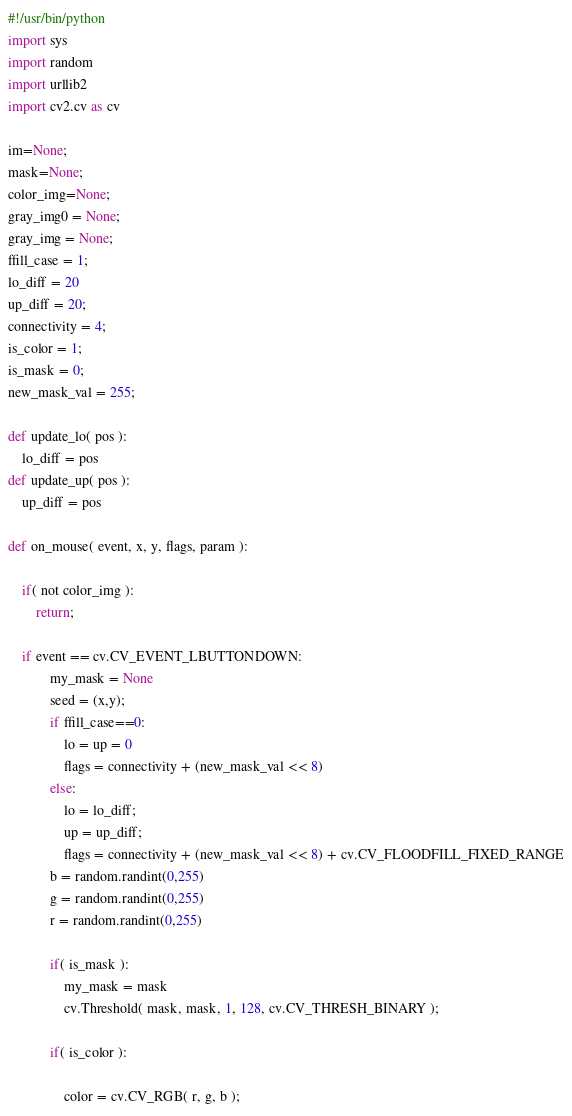Convert code to text. <code><loc_0><loc_0><loc_500><loc_500><_Python_>#!/usr/bin/python
import sys
import random
import urllib2
import cv2.cv as cv

im=None;
mask=None;
color_img=None;
gray_img0 = None;
gray_img = None;
ffill_case = 1;
lo_diff = 20
up_diff = 20;
connectivity = 4;
is_color = 1;
is_mask = 0;
new_mask_val = 255;

def update_lo( pos ):
    lo_diff = pos
def update_up( pos ):
    up_diff = pos

def on_mouse( event, x, y, flags, param ):

    if( not color_img ):
        return;

    if event == cv.CV_EVENT_LBUTTONDOWN:
            my_mask = None
            seed = (x,y);
            if ffill_case==0:
                lo = up = 0
                flags = connectivity + (new_mask_val << 8)
            else:
                lo = lo_diff;
                up = up_diff;
                flags = connectivity + (new_mask_val << 8) + cv.CV_FLOODFILL_FIXED_RANGE
            b = random.randint(0,255)
            g = random.randint(0,255)
            r = random.randint(0,255)

            if( is_mask ):
                my_mask = mask
                cv.Threshold( mask, mask, 1, 128, cv.CV_THRESH_BINARY );

            if( is_color ):

                color = cv.CV_RGB( r, g, b );</code> 